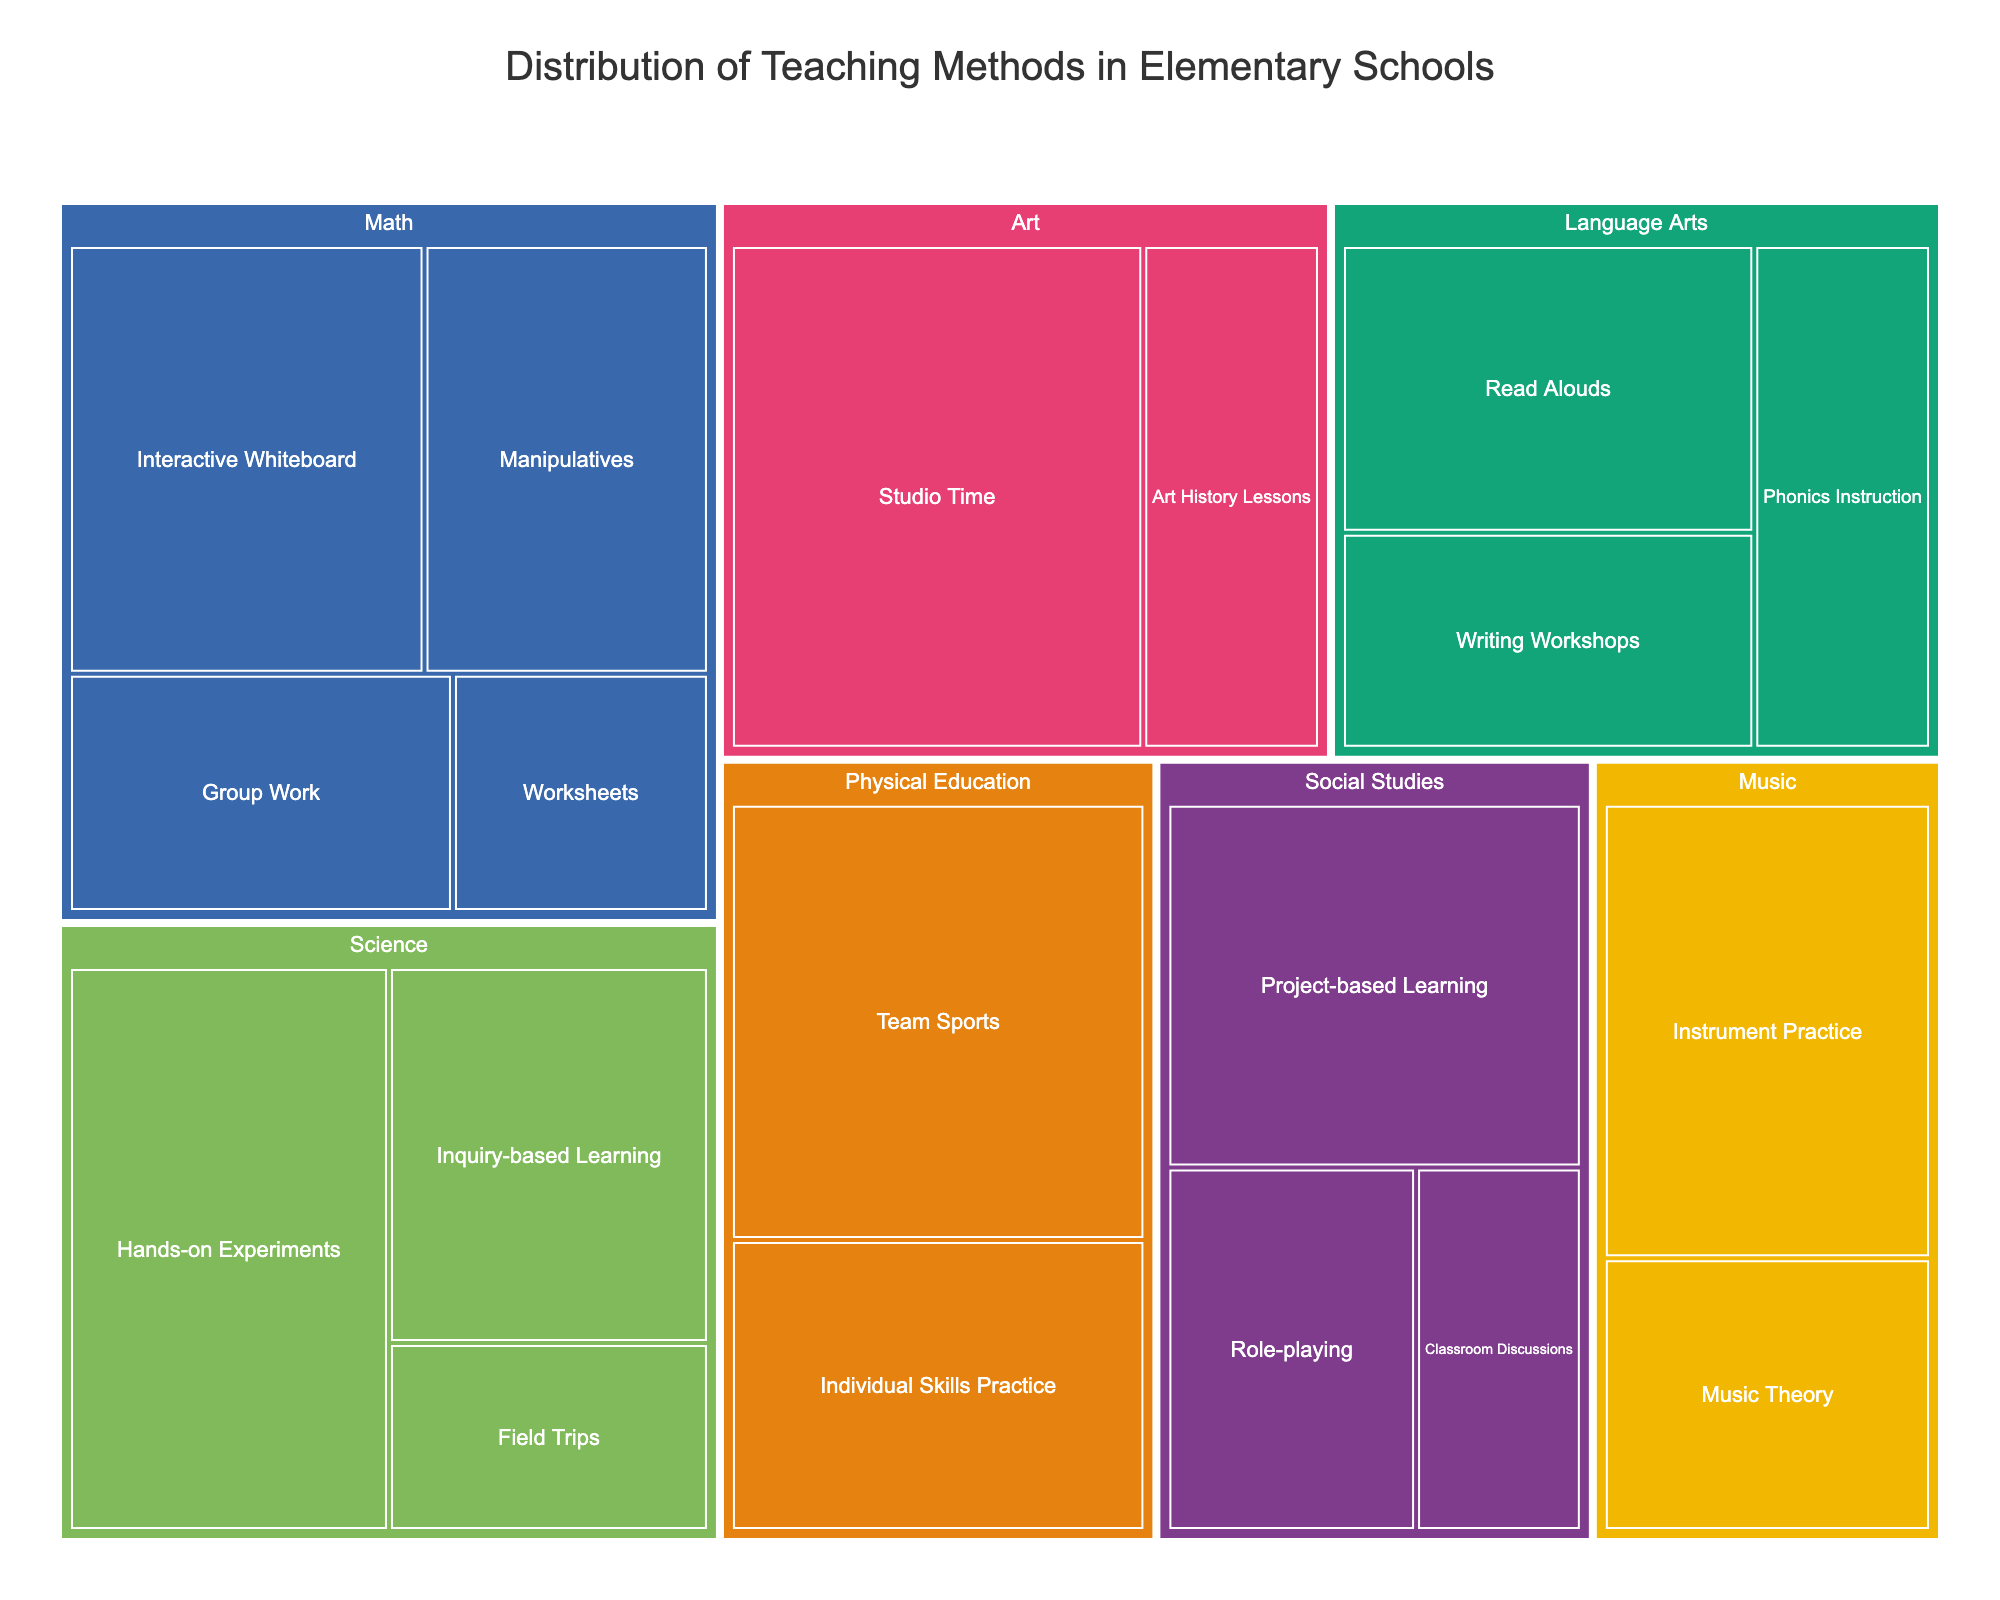What is the title of the figure? The title is usually placed at the top of the plot. By looking at the top, you will see the main title of the figure.
Answer: Distribution of Teaching Methods in Elementary Schools Which teaching method is most prevalent in Science? The treemap allows us to see the area designated for each method. The biggest segment for Science represents the most prevalent method.
Answer: Hands-on Experiments What percentage of teaching methods in Social Studies is dedicated to Role-playing and Classroom Discussions combined? Add the percentages of Role-playing and Classroom Discussions within the Social Studies category.
Answer: 15% + 10% = 25% How does the use of Read Alouds in Language Arts compare to the use of Project-based Learning in Social Studies? Compare the sizes of the Read Alouds segment in Language Arts and the Project-based Learning segment in Social Studies.
Answer: Read Alouds: 20%, Project-based Learning: 25%, so Project-based Learning is higher Which subject has the method with the highest single percentage, and what is that percentage? Compare the largest segments of each subject; the largest segment across all subjects will be the answer.
Answer: Art, Studio Time with 35% Are there more diverse teaching methods used in Math or in Physical Education? Count the number of different methods represented in the treemap for Math and Physical Education.
Answer: Math: 4, Physical Education: 2, so Math has more diverse methods How does the distribution of teaching methods differ between Math and Language Arts? Compare the different methods and their percentages that fall under Math with those under Language Arts.
Answer: Math: Interactive Whiteboard 25%, Manipulatives 20%, Group Work 15%, Worksheets 10%. Language Arts: Read Alouds 20%, Writing Workshops 15%, Phonics Instruction 15% Which subjects have at least one teaching method constituting 30% or more? Look for subjects with any segment having 30% or more area.
Answer: Science, Art, Physical Education What’s the combined percentage of Group Work and Worksheets in Math? Add the percentages of Group Work and Worksheets in the Math category.
Answer: 15% + 10% = 25% Which subject has the smallest representation for any teaching method, and which method is it? Identify the smallest area within each subject; the overall smallest area will be the answer.
Answer: Social Studies, Classroom Discussions with 10% 